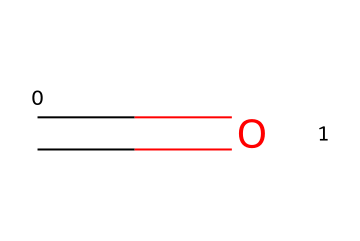What is the molecular formula of this compound? The visual representation shows one carbon atom and one oxygen atom, which indicates a simple molecular structure. To derive the molecular formula, we count the number of each type of atom. There's one carbon (C) and one oxygen (O), leading to the formula CH2O, commonly known as formaldehyde.
Answer: CH2O How many bonds are present in the structure? In the provided SMILES representation, the C=O indicates a double bond between the carbon and oxygen. Each bond is counted, and here, we find one double bond, giving a total of one bond in the structure.
Answer: one What type of compound is formaldehyde considered? Analyzing the structure, formaldehyde consists of a carbon atom that is double-bonded to an oxygen atom, fitting the characteristics of an aldehyde. Aldehydes contain a carbonyl group (C=O) at the end of a carbon chain.
Answer: aldehyde Does this compound have any hydrogen atoms? Since the structure contains one carbon atom (as per the carbonyl group C=O) and operates under the standard valency of carbon, it must have enough hydrogen atoms to satisfy carbon's four bonds. As a simple molecule, it has two hydrogen atoms attached to the carbon to complete its bonding requirements.
Answer: yes Can this compound exist as a carbene? Reviewing the structure, there is no availability of a lone pair and no functionality from the shown double bond that would allow a carbon to contain an empty p orbital needed for carbene formation. Carbenes are very reactive species with two unshared electrons, which is not represented here in formaldehyde.
Answer: no What is the common use of formaldehyde in manufacturing? The structure indicates a simple and reactive molecule, making it useful as a preservative in various applications, particularly in wood manufacturing due to its ability to prevent decay and kill pests. This presents a practical perspective on this compound's application in preserving materials.
Answer: wood preservative 